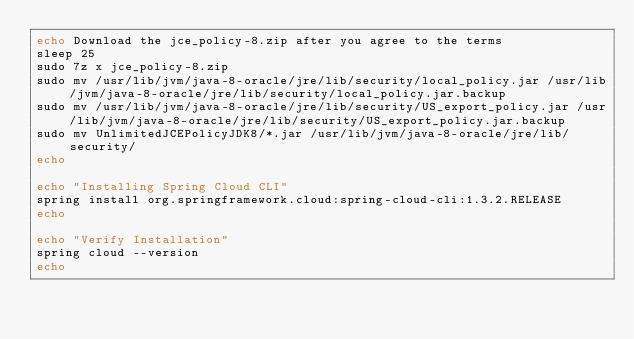Convert code to text. <code><loc_0><loc_0><loc_500><loc_500><_Bash_>echo Download the jce_policy-8.zip after you agree to the terms
sleep 25
sudo 7z x jce_policy-8.zip
sudo mv /usr/lib/jvm/java-8-oracle/jre/lib/security/local_policy.jar /usr/lib/jvm/java-8-oracle/jre/lib/security/local_policy.jar.backup
sudo mv /usr/lib/jvm/java-8-oracle/jre/lib/security/US_export_policy.jar /usr/lib/jvm/java-8-oracle/jre/lib/security/US_export_policy.jar.backup
sudo mv UnlimitedJCEPolicyJDK8/*.jar /usr/lib/jvm/java-8-oracle/jre/lib/security/
echo

echo "Installing Spring Cloud CLI"
spring install org.springframework.cloud:spring-cloud-cli:1.3.2.RELEASE
echo

echo "Verify Installation"
spring cloud --version
echo</code> 